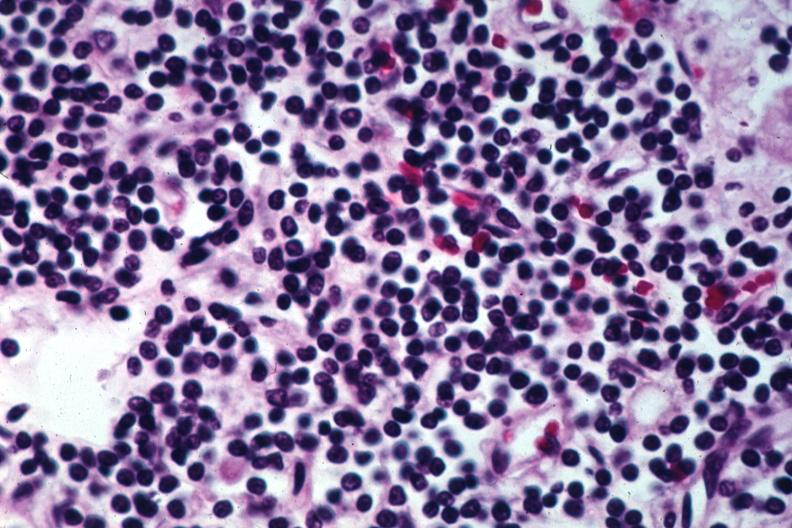what does this image show?
Answer the question using a single word or phrase. Pleomorphic small lymphocytes 